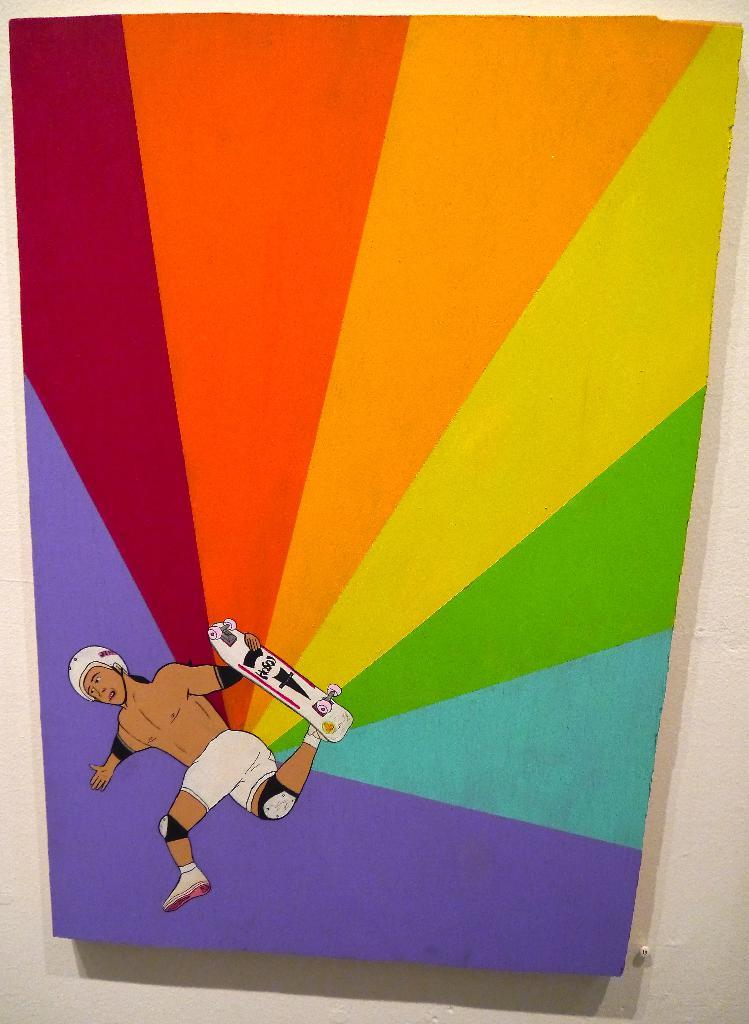What is the main subject of the painting in the image? The painting depicts a person holding a skateboard. What can be seen on the skateboard in the painting? The skateboard has a design on it. Where are the painting and the skateboard design located in the image? The painting and the skateboard design are on the wall. What type of health system is depicted in the painting? There is no health system depicted in the painting; it features a person holding a skateboard. Can you describe the kiss between the two people in the painting? There are no people kissing in the painting; it only depicts a person holding a skateboard. 